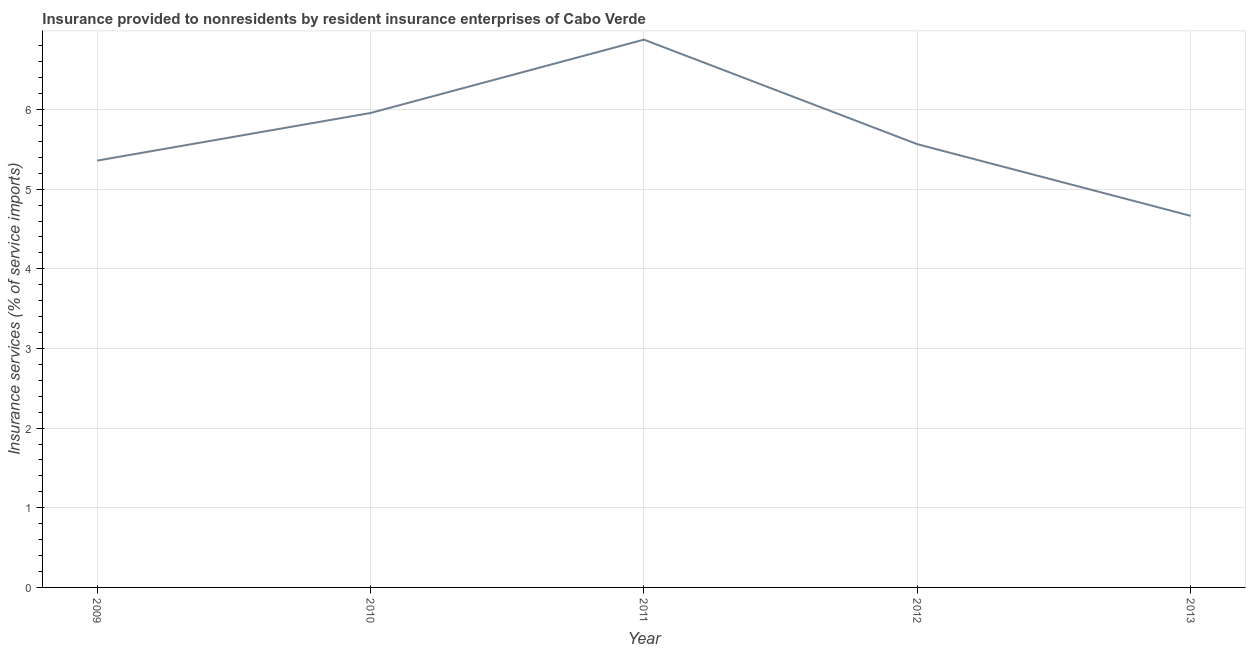What is the insurance and financial services in 2009?
Your response must be concise. 5.36. Across all years, what is the maximum insurance and financial services?
Offer a terse response. 6.88. Across all years, what is the minimum insurance and financial services?
Offer a terse response. 4.66. What is the sum of the insurance and financial services?
Provide a succinct answer. 28.42. What is the difference between the insurance and financial services in 2009 and 2012?
Keep it short and to the point. -0.21. What is the average insurance and financial services per year?
Provide a short and direct response. 5.68. What is the median insurance and financial services?
Keep it short and to the point. 5.56. Do a majority of the years between 2010 and 2009 (inclusive) have insurance and financial services greater than 1 %?
Provide a short and direct response. No. What is the ratio of the insurance and financial services in 2009 to that in 2013?
Your response must be concise. 1.15. What is the difference between the highest and the second highest insurance and financial services?
Provide a short and direct response. 0.92. Is the sum of the insurance and financial services in 2010 and 2012 greater than the maximum insurance and financial services across all years?
Give a very brief answer. Yes. What is the difference between the highest and the lowest insurance and financial services?
Ensure brevity in your answer.  2.21. In how many years, is the insurance and financial services greater than the average insurance and financial services taken over all years?
Your answer should be compact. 2. Does the insurance and financial services monotonically increase over the years?
Offer a terse response. No. How many years are there in the graph?
Give a very brief answer. 5. Does the graph contain grids?
Keep it short and to the point. Yes. What is the title of the graph?
Provide a succinct answer. Insurance provided to nonresidents by resident insurance enterprises of Cabo Verde. What is the label or title of the Y-axis?
Make the answer very short. Insurance services (% of service imports). What is the Insurance services (% of service imports) of 2009?
Offer a very short reply. 5.36. What is the Insurance services (% of service imports) of 2010?
Provide a short and direct response. 5.96. What is the Insurance services (% of service imports) of 2011?
Your answer should be compact. 6.88. What is the Insurance services (% of service imports) of 2012?
Your response must be concise. 5.56. What is the Insurance services (% of service imports) in 2013?
Make the answer very short. 4.66. What is the difference between the Insurance services (% of service imports) in 2009 and 2010?
Provide a short and direct response. -0.6. What is the difference between the Insurance services (% of service imports) in 2009 and 2011?
Provide a succinct answer. -1.52. What is the difference between the Insurance services (% of service imports) in 2009 and 2012?
Your response must be concise. -0.21. What is the difference between the Insurance services (% of service imports) in 2009 and 2013?
Your answer should be compact. 0.69. What is the difference between the Insurance services (% of service imports) in 2010 and 2011?
Give a very brief answer. -0.92. What is the difference between the Insurance services (% of service imports) in 2010 and 2012?
Offer a terse response. 0.39. What is the difference between the Insurance services (% of service imports) in 2010 and 2013?
Your response must be concise. 1.29. What is the difference between the Insurance services (% of service imports) in 2011 and 2012?
Ensure brevity in your answer.  1.31. What is the difference between the Insurance services (% of service imports) in 2011 and 2013?
Your answer should be very brief. 2.21. What is the difference between the Insurance services (% of service imports) in 2012 and 2013?
Give a very brief answer. 0.9. What is the ratio of the Insurance services (% of service imports) in 2009 to that in 2011?
Your answer should be compact. 0.78. What is the ratio of the Insurance services (% of service imports) in 2009 to that in 2012?
Your answer should be compact. 0.96. What is the ratio of the Insurance services (% of service imports) in 2009 to that in 2013?
Offer a terse response. 1.15. What is the ratio of the Insurance services (% of service imports) in 2010 to that in 2011?
Your response must be concise. 0.87. What is the ratio of the Insurance services (% of service imports) in 2010 to that in 2012?
Ensure brevity in your answer.  1.07. What is the ratio of the Insurance services (% of service imports) in 2010 to that in 2013?
Keep it short and to the point. 1.28. What is the ratio of the Insurance services (% of service imports) in 2011 to that in 2012?
Provide a short and direct response. 1.24. What is the ratio of the Insurance services (% of service imports) in 2011 to that in 2013?
Your answer should be compact. 1.47. What is the ratio of the Insurance services (% of service imports) in 2012 to that in 2013?
Keep it short and to the point. 1.19. 